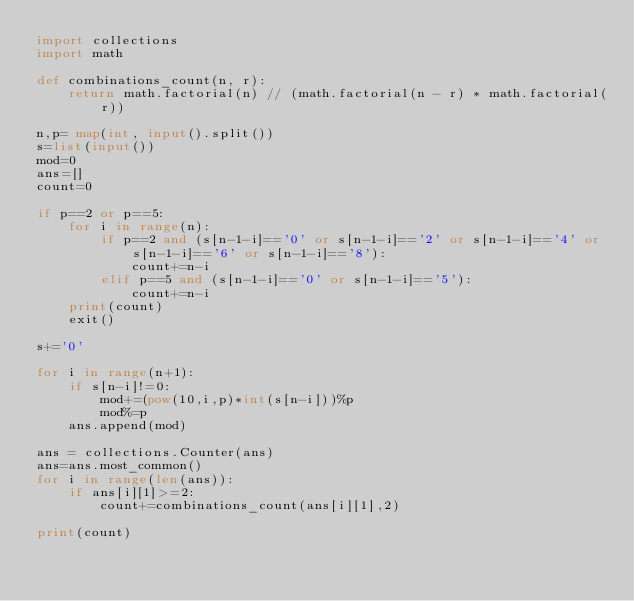Convert code to text. <code><loc_0><loc_0><loc_500><loc_500><_Python_>import collections
import math

def combinations_count(n, r):
    return math.factorial(n) // (math.factorial(n - r) * math.factorial(r))

n,p= map(int, input().split())
s=list(input())
mod=0
ans=[]
count=0

if p==2 or p==5:
    for i in range(n):
        if p==2 and (s[n-1-i]=='0' or s[n-1-i]=='2' or s[n-1-i]=='4' or s[n-1-i]=='6' or s[n-1-i]=='8'):
            count+=n-i
        elif p==5 and (s[n-1-i]=='0' or s[n-1-i]=='5'):
            count+=n-i
    print(count)
    exit()

s+='0'

for i in range(n+1):
    if s[n-i]!=0:
        mod+=(pow(10,i,p)*int(s[n-i]))%p
        mod%=p
    ans.append(mod)

ans = collections.Counter(ans)
ans=ans.most_common()
for i in range(len(ans)):
    if ans[i][1]>=2:
        count+=combinations_count(ans[i][1],2)

print(count)</code> 